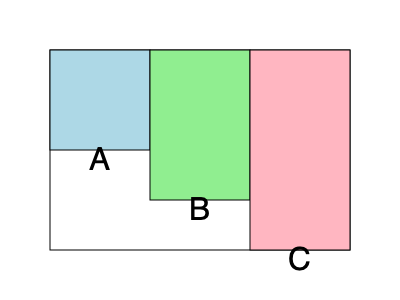In a Minecraft world, you've built three tower structures made of cubes, as shown in the diagram. Tower A is 5 blocks wide, 5 blocks long, and 10 blocks high. Tower B is 5 blocks wide, 5 blocks long, and 15 blocks high. Tower C is 5 blocks wide, 5 blocks long, and 20 blocks high. What is the total volume of all three towers combined in cubic blocks? Let's calculate the volume of each tower step-by-step:

1. Tower A:
   - Width: 5 blocks
   - Length: 5 blocks
   - Height: 10 blocks
   - Volume of A = $5 \times 5 \times 10 = 250$ cubic blocks

2. Tower B:
   - Width: 5 blocks
   - Length: 5 blocks
   - Height: 15 blocks
   - Volume of B = $5 \times 5 \times 15 = 375$ cubic blocks

3. Tower C:
   - Width: 5 blocks
   - Length: 5 blocks
   - Height: 20 blocks
   - Volume of C = $5 \times 5 \times 20 = 500$ cubic blocks

4. Total volume:
   - Sum of all tower volumes = Volume of A + Volume of B + Volume of C
   - Total volume = $250 + 375 + 500 = 1125$ cubic blocks

Therefore, the total volume of all three towers combined is 1125 cubic blocks.
Answer: 1125 cubic blocks 